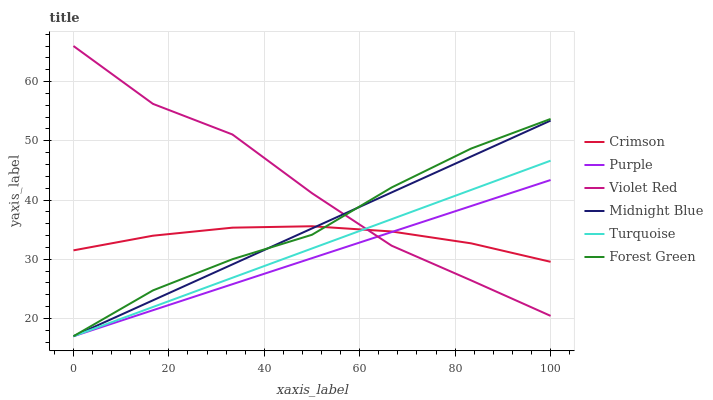Does Midnight Blue have the minimum area under the curve?
Answer yes or no. No. Does Midnight Blue have the maximum area under the curve?
Answer yes or no. No. Is Purple the smoothest?
Answer yes or no. No. Is Purple the roughest?
Answer yes or no. No. Does Crimson have the lowest value?
Answer yes or no. No. Does Midnight Blue have the highest value?
Answer yes or no. No. 